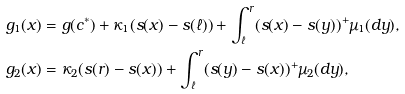Convert formula to latex. <formula><loc_0><loc_0><loc_500><loc_500>g _ { 1 } ( x ) & = g ( c ^ { * } ) + \kappa _ { 1 } ( s ( x ) - s ( \ell ) ) + \int _ { \ell } ^ { r } ( s ( x ) - s ( y ) ) ^ { + } \mu _ { 1 } ( d y ) , \\ g _ { 2 } ( x ) & = \kappa _ { 2 } ( s ( r ) - s ( x ) ) + \int _ { \ell } ^ { r } ( s ( y ) - s ( x ) ) ^ { + } \mu _ { 2 } ( d y ) ,</formula> 